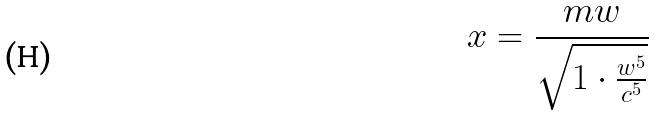Convert formula to latex. <formula><loc_0><loc_0><loc_500><loc_500>x = \frac { m w } { \sqrt { 1 \cdot \frac { w ^ { 5 } } { c ^ { 5 } } } }</formula> 